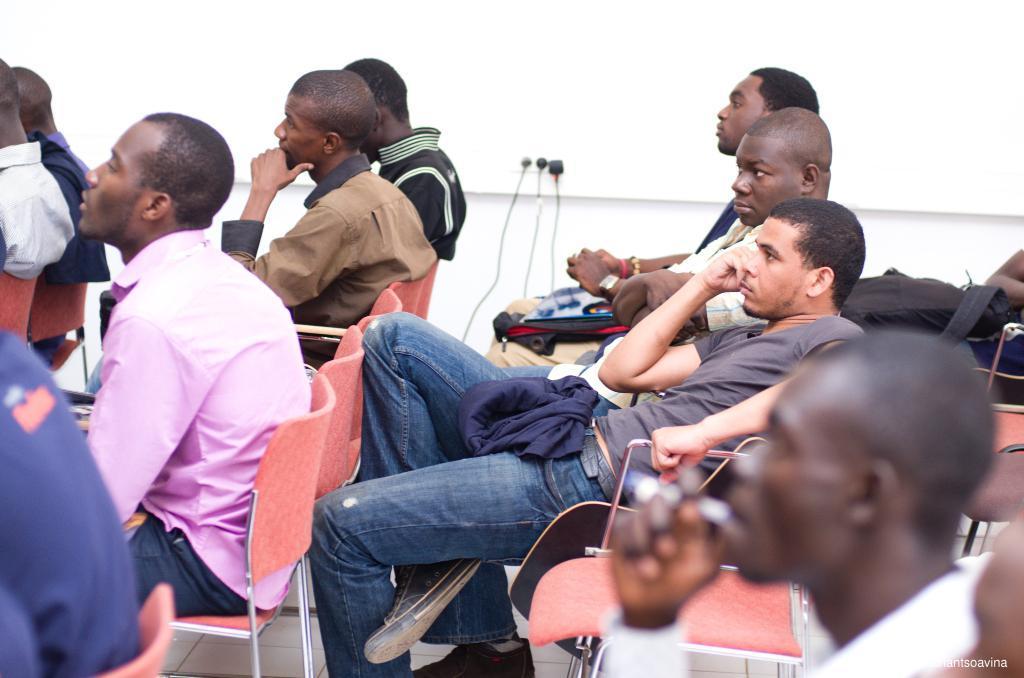How would you summarize this image in a sentence or two? In this image I can see group of people are sitting on the chairs. In the background I can see a wall off white in color and sockets. This image is taken in a hall. 